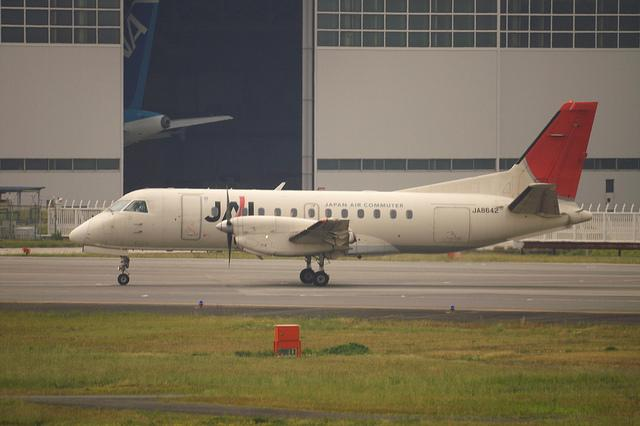What color is the tip of the tailfin on the Japanese propeller plane?

Choices:
A) green
B) orange
C) red
D) brown red 